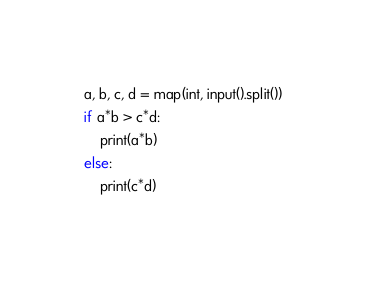Convert code to text. <code><loc_0><loc_0><loc_500><loc_500><_Python_>a, b, c, d = map(int, input().split())
if a*b > c*d:
    print(a*b)
else:
    print(c*d)</code> 